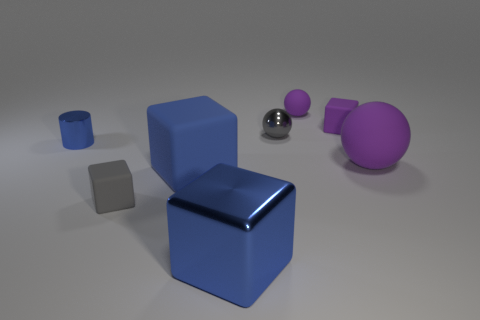Subtract all gray blocks. How many blocks are left? 3 Subtract all green cylinders. How many blue cubes are left? 2 Add 2 tiny metal cylinders. How many objects exist? 10 Subtract all spheres. How many objects are left? 5 Subtract 2 balls. How many balls are left? 1 Subtract all red cubes. Subtract all cyan balls. How many cubes are left? 4 Subtract all small cyan metal cylinders. Subtract all small spheres. How many objects are left? 6 Add 5 small matte spheres. How many small matte spheres are left? 6 Add 4 cyan cylinders. How many cyan cylinders exist? 4 Subtract all gray balls. How many balls are left? 2 